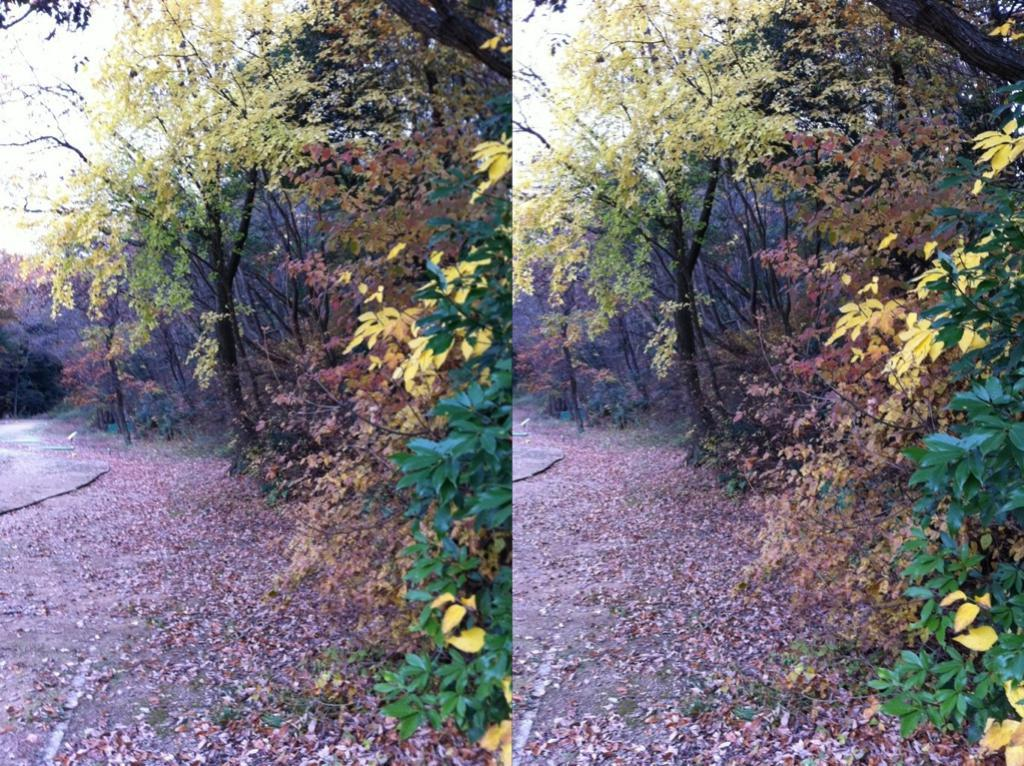What type of photos can be seen in the image? There are college photos in the image. What natural elements are present in the image? There are trees and dry leaves visible in the image. What part of the natural environment is visible in the image? The sky is visible in the image. What type of popcorn is being served at the college event in the image? There is no popcorn present in the image; it only features college photos, trees, dry leaves, and the sky. Can you tell me how many porters are assisting with the college event in the image? There is no indication of any porters or events in the image; it only shows college photos, trees, dry leaves, and the sky. 